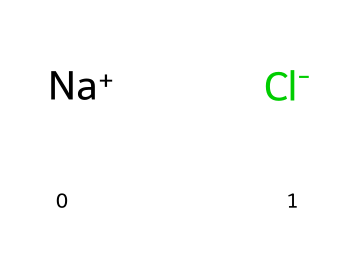What is the name of this chemical? The chemical depicted is commonly known as table salt, which is the everyday name for sodium chloride.
Answer: sodium chloride How many elements are present in this compound? The SMILES representation shows two distinct ions: sodium (Na) and chlorine (Cl), indicating the presence of two elements.
Answer: two What charges do the ions in this chemical have? The representation indicates that sodium carries a positive charge ([Na+]) while chlorine carries a negative charge ([Cl-]).
Answer: positive and negative What type of bond is formed between the ions of this chemical? Sodium chloride forms an ionic bond due to the electrostatic attraction between the positively charged sodium ion and the negatively charged chloride ion.
Answer: ionic bond What is the chemical formula of this compound? The combination of sodium and chloride leads to the simplest form of the compound, which is represented by the chemical formula NaCl.
Answer: NaCl Why is sodium chloride classified as an inorganic compound? Sodium chloride is considered inorganic because it does not contain carbon-hydrogen (C-H) bonds, typical for organic substances, and is composed of mineral ions.
Answer: inorganic What is the state of sodium chloride at room temperature? At room temperature, sodium chloride typically exists as a solid crystalline structure, which can be inferred from its common usage as table salt.
Answer: solid 